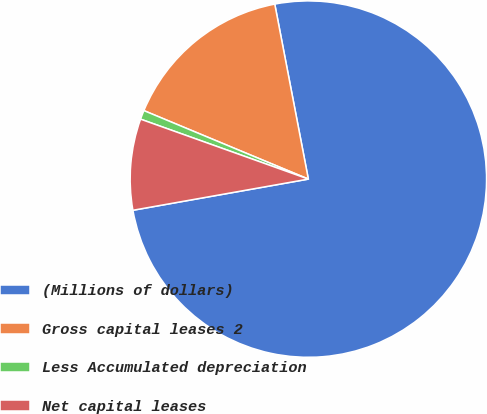Convert chart. <chart><loc_0><loc_0><loc_500><loc_500><pie_chart><fcel>(Millions of dollars)<fcel>Gross capital leases 2<fcel>Less Accumulated depreciation<fcel>Net capital leases<nl><fcel>75.22%<fcel>15.7%<fcel>0.82%<fcel>8.26%<nl></chart> 